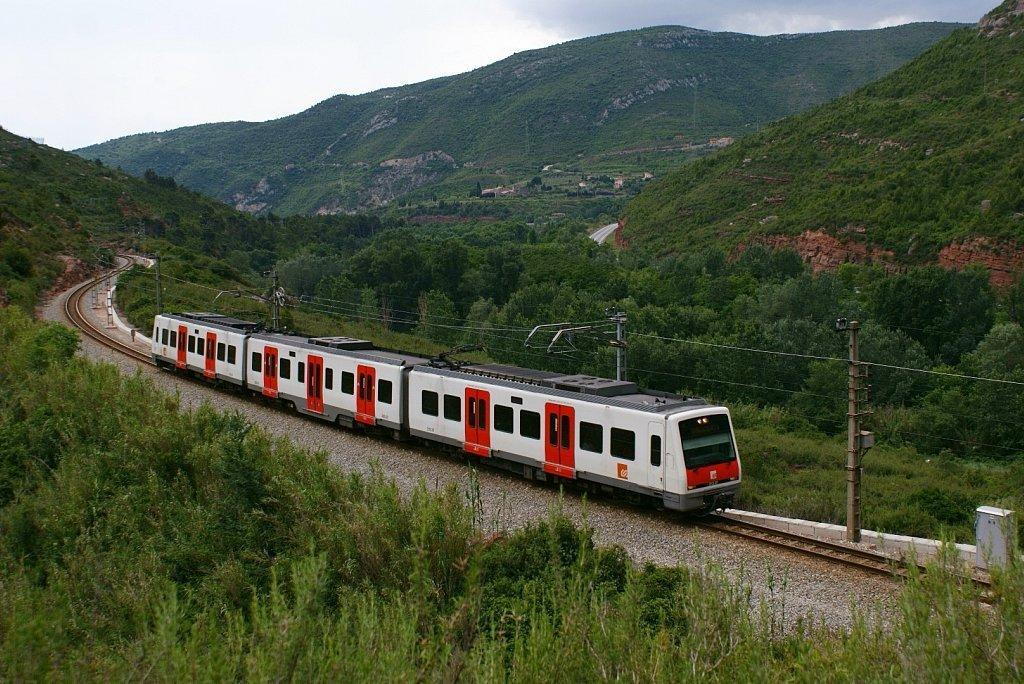Could you give a brief overview of what you see in this image? Here we can see a train on a railway track and there are poles and wires. To either side of the track there are trees and plants. In the background there are trees, mountain, houses and clouds in the sky. 